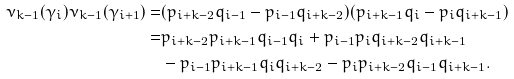Convert formula to latex. <formula><loc_0><loc_0><loc_500><loc_500>\nu _ { k - 1 } ( \gamma _ { i } ) \nu _ { k - 1 } ( \gamma _ { i + 1 } ) = & ( p _ { i + k - 2 } q _ { i - 1 } - p _ { i - 1 } q _ { i + k - 2 } ) ( p _ { i + k - 1 } q _ { i } - p _ { i } q _ { i + k - 1 } ) \\ = & p _ { i + k - 2 } p _ { i + k - 1 } q _ { i - 1 } q _ { i } + p _ { i - 1 } p _ { i } q _ { i + k - 2 } q _ { i + k - 1 } \\ & - p _ { i - 1 } p _ { i + k - 1 } q _ { i } q _ { i + k - 2 } - p _ { i } p _ { i + k - 2 } q _ { i - 1 } q _ { i + k - 1 } .</formula> 